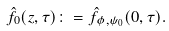<formula> <loc_0><loc_0><loc_500><loc_500>\hat { f } _ { 0 } ( z , \tau ) \colon = \hat { f } _ { \phi , \psi _ { 0 } } ( 0 , \tau ) .</formula> 